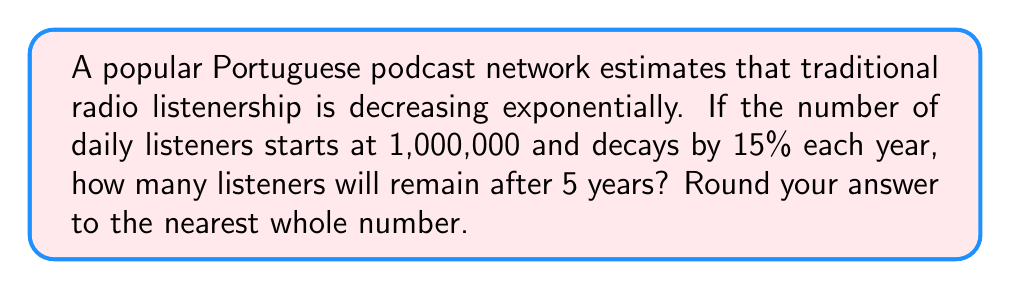Could you help me with this problem? Let's approach this step-by-step using the exponential decay formula:

1) The exponential decay formula is:
   $$A(t) = A_0 \cdot (1-r)^t$$
   Where:
   $A(t)$ is the amount after time $t$
   $A_0$ is the initial amount
   $r$ is the decay rate (as a decimal)
   $t$ is the time period

2) We know:
   $A_0 = 1,000,000$ (initial listeners)
   $r = 0.15$ (15% decay rate)
   $t = 5$ (years)

3) Let's plug these values into our formula:
   $$A(5) = 1,000,000 \cdot (1-0.15)^5$$

4) Simplify inside the parentheses:
   $$A(5) = 1,000,000 \cdot (0.85)^5$$

5) Calculate $(0.85)^5$:
   $$(0.85)^5 \approx 0.4437$$

6) Multiply:
   $$1,000,000 \cdot 0.4437 \approx 443,700$$

7) Rounding to the nearest whole number:
   $$443,700 \approx 443,700$$

Therefore, after 5 years, approximately 443,700 listeners will remain.
Answer: 443,700 listeners 